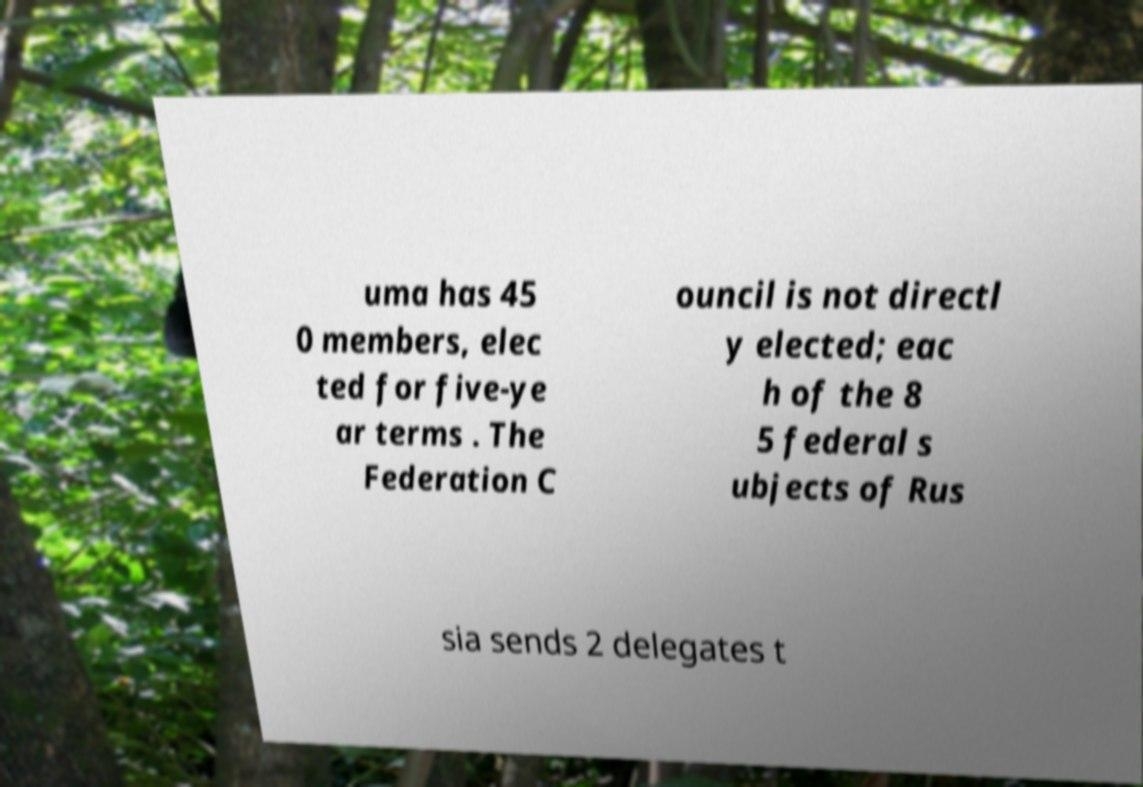What messages or text are displayed in this image? I need them in a readable, typed format. uma has 45 0 members, elec ted for five-ye ar terms . The Federation C ouncil is not directl y elected; eac h of the 8 5 federal s ubjects of Rus sia sends 2 delegates t 